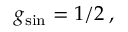<formula> <loc_0><loc_0><loc_500><loc_500>g _ { \sin } = 1 / 2 \, ,</formula> 